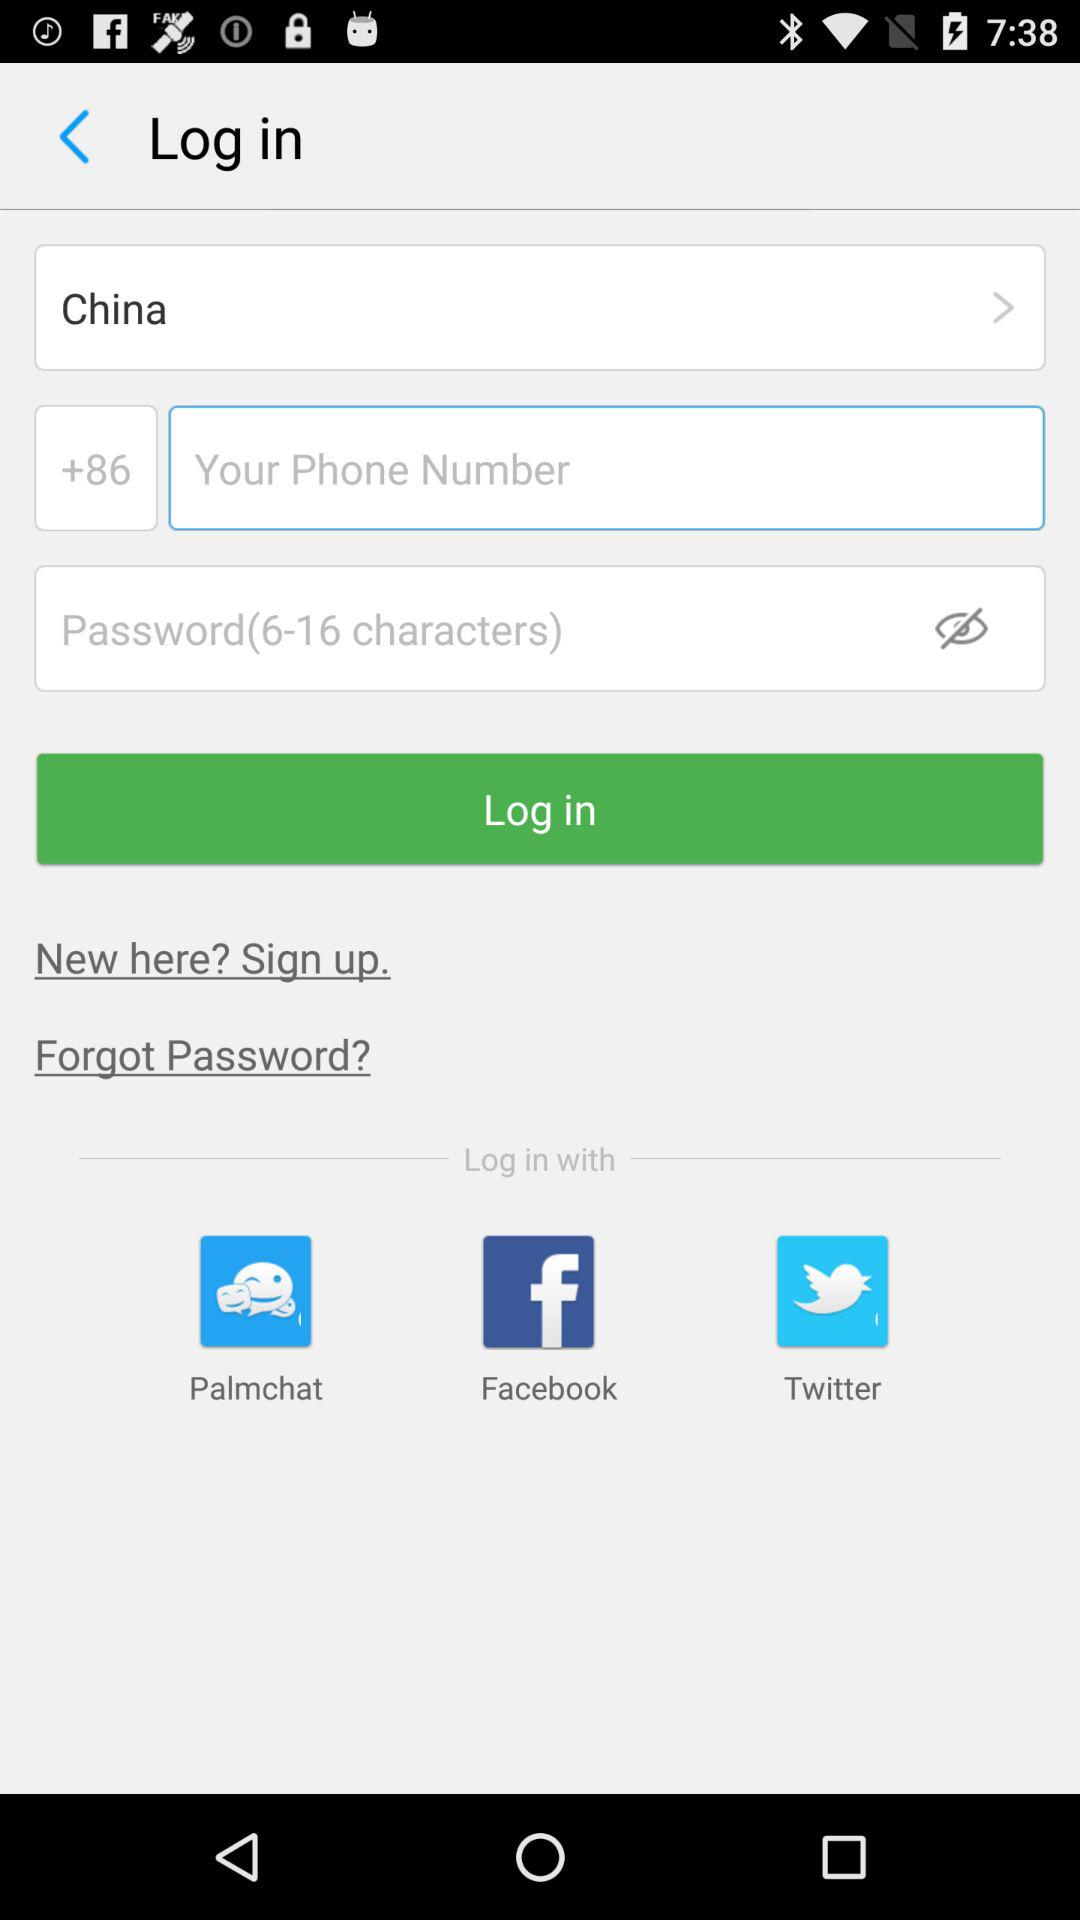What country has been selected? The selected country is China. 